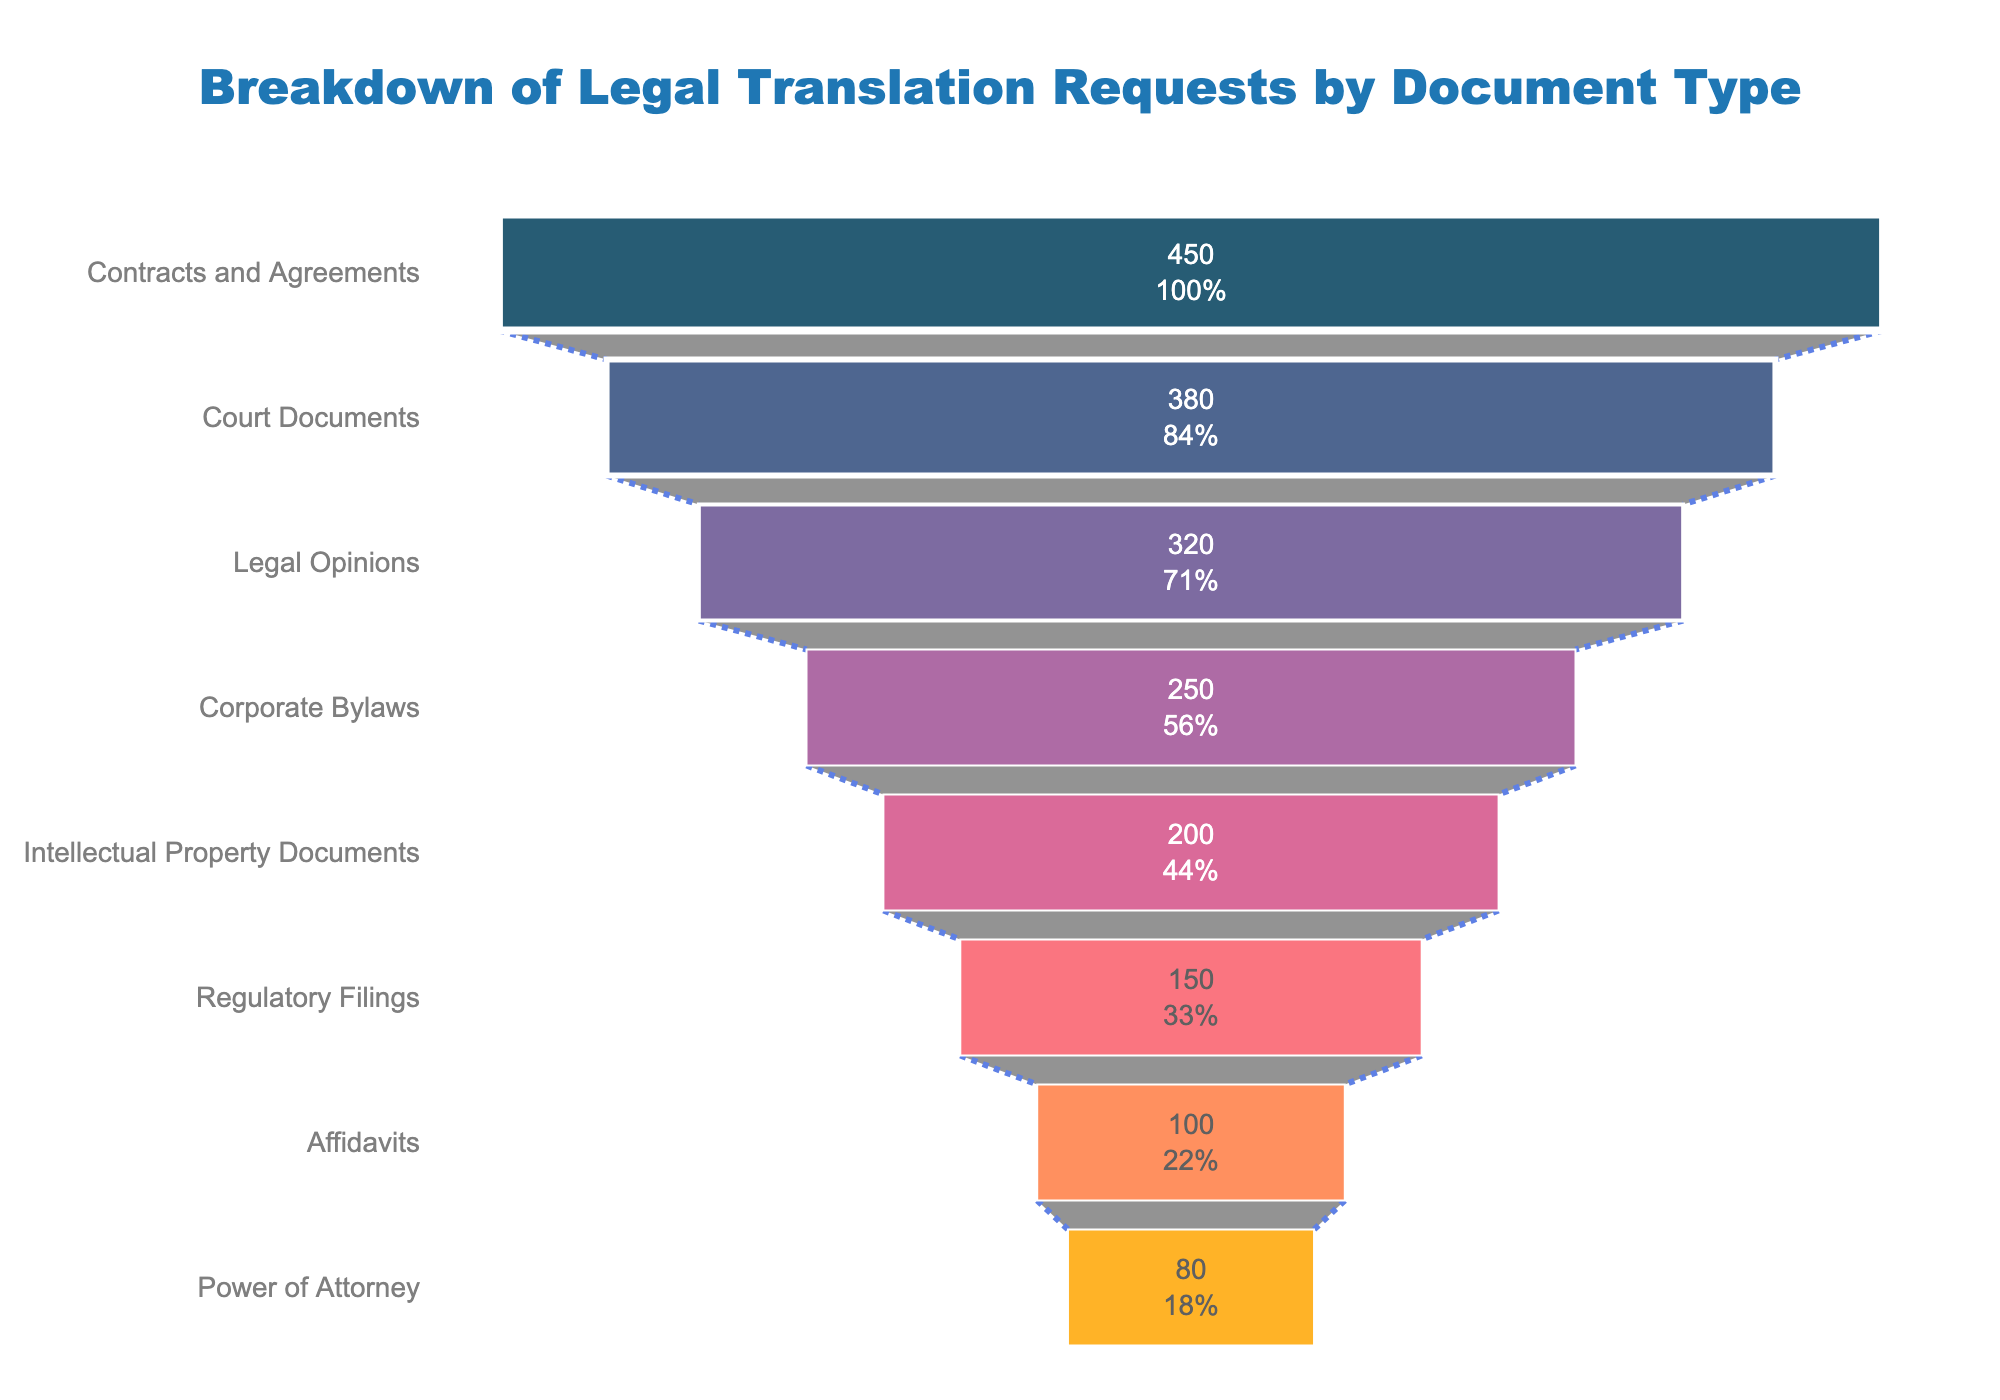What type of document received the highest number of requests? The funnel chart displays different types of documents with varying numbers of requests. The topmost item in the funnel represents the document type with the highest number.
Answer: Contracts and Agreements Which document type accounts for the second-highest number of requests? By looking at the position of the document types in the funnel chart, the second item from the top represents the document type with the second-highest number of requests.
Answer: Court Documents What percentage of requests were for Legal Opinions? The funnel chart usually provides not just the absolute numbers but also percentages. Locate Legal Opinions in the chart and read the percentage value from it.
Answer: 18.2% How many more requests were made for Contracts and Agreements than for Regulatory Filings? Identify the number of requests for Contracts and Agreements and Regulatory Filings from the funnel chart and subtract the latter from the former.
Answer: 300 Which document type had the least number of requests? The funnel chart orders document types from the highest to the lowest number of requests, making the bottommost item the one with the least requests.
Answer: Power of Attorney What document types had less than 200 requests each? Check each bar in the funnel chart and list the document types with values under 200.
Answer: Intellectual Property Documents, Regulatory Filings, Affidavits, Power of Attorney What is the combined number of requests for Court Documents and Corporate Bylaws? Sum the numbers of requests for Court Documents and Corporate Bylaws, as indicated on the funnel chart.
Answer: 630 How does the number of requests for Corporate Bylaws compare to those for Legal Opinions? Locate both Corporate Bylaws and Legal Opinions on the funnel chart and compare their values.
Answer: Legal Opinions has more requests than Corporate Bylaws Calculate the difference in number of requests between the second-most and the third-most requested document types. Identify the second and third document types based on the funnel chart, which are Court Documents and Legal Opinions, respectively, and subtract the latter from the former.
Answer: 60 What is the sum of requests for the three least requested document types? Identify and sum the number of requests for Regulatory Filings, Affidavits, and Power of Attorney from the funnel chart.
Answer: 330 